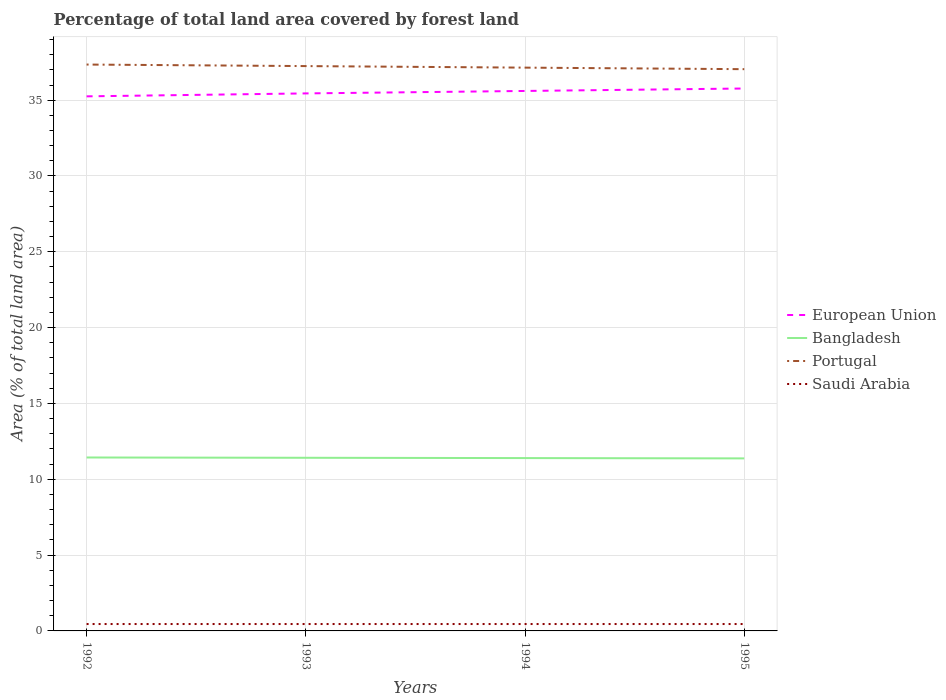How many different coloured lines are there?
Your answer should be compact. 4. Across all years, what is the maximum percentage of forest land in European Union?
Offer a terse response. 35.25. In which year was the percentage of forest land in Portugal maximum?
Ensure brevity in your answer.  1995. What is the total percentage of forest land in Bangladesh in the graph?
Your response must be concise. 0.02. What is the difference between the highest and the second highest percentage of forest land in Bangladesh?
Give a very brief answer. 0.06. What is the difference between the highest and the lowest percentage of forest land in Bangladesh?
Offer a very short reply. 2. How many lines are there?
Provide a succinct answer. 4. Are the values on the major ticks of Y-axis written in scientific E-notation?
Keep it short and to the point. No. What is the title of the graph?
Your response must be concise. Percentage of total land area covered by forest land. What is the label or title of the Y-axis?
Make the answer very short. Area (% of total land area). What is the Area (% of total land area) in European Union in 1992?
Offer a terse response. 35.25. What is the Area (% of total land area) of Bangladesh in 1992?
Ensure brevity in your answer.  11.44. What is the Area (% of total land area) in Portugal in 1992?
Keep it short and to the point. 37.35. What is the Area (% of total land area) in Saudi Arabia in 1992?
Offer a terse response. 0.45. What is the Area (% of total land area) in European Union in 1993?
Your response must be concise. 35.45. What is the Area (% of total land area) of Bangladesh in 1993?
Offer a terse response. 11.42. What is the Area (% of total land area) of Portugal in 1993?
Your answer should be very brief. 37.25. What is the Area (% of total land area) of Saudi Arabia in 1993?
Your answer should be compact. 0.45. What is the Area (% of total land area) of European Union in 1994?
Make the answer very short. 35.61. What is the Area (% of total land area) of Bangladesh in 1994?
Offer a terse response. 11.4. What is the Area (% of total land area) of Portugal in 1994?
Your response must be concise. 37.15. What is the Area (% of total land area) of Saudi Arabia in 1994?
Keep it short and to the point. 0.45. What is the Area (% of total land area) in European Union in 1995?
Offer a terse response. 35.77. What is the Area (% of total land area) of Bangladesh in 1995?
Your answer should be compact. 11.38. What is the Area (% of total land area) of Portugal in 1995?
Offer a terse response. 37.04. What is the Area (% of total land area) of Saudi Arabia in 1995?
Offer a very short reply. 0.45. Across all years, what is the maximum Area (% of total land area) in European Union?
Make the answer very short. 35.77. Across all years, what is the maximum Area (% of total land area) in Bangladesh?
Your answer should be compact. 11.44. Across all years, what is the maximum Area (% of total land area) of Portugal?
Give a very brief answer. 37.35. Across all years, what is the maximum Area (% of total land area) of Saudi Arabia?
Provide a short and direct response. 0.45. Across all years, what is the minimum Area (% of total land area) of European Union?
Your answer should be very brief. 35.25. Across all years, what is the minimum Area (% of total land area) in Bangladesh?
Make the answer very short. 11.38. Across all years, what is the minimum Area (% of total land area) in Portugal?
Your answer should be very brief. 37.04. Across all years, what is the minimum Area (% of total land area) of Saudi Arabia?
Keep it short and to the point. 0.45. What is the total Area (% of total land area) of European Union in the graph?
Offer a terse response. 142.07. What is the total Area (% of total land area) in Bangladesh in the graph?
Make the answer very short. 45.63. What is the total Area (% of total land area) of Portugal in the graph?
Offer a very short reply. 148.78. What is the total Area (% of total land area) of Saudi Arabia in the graph?
Make the answer very short. 1.82. What is the difference between the Area (% of total land area) in European Union in 1992 and that in 1993?
Offer a terse response. -0.19. What is the difference between the Area (% of total land area) in Bangladesh in 1992 and that in 1993?
Your answer should be compact. 0.02. What is the difference between the Area (% of total land area) in Portugal in 1992 and that in 1993?
Make the answer very short. 0.1. What is the difference between the Area (% of total land area) of European Union in 1992 and that in 1994?
Give a very brief answer. -0.35. What is the difference between the Area (% of total land area) in Bangladesh in 1992 and that in 1994?
Your response must be concise. 0.04. What is the difference between the Area (% of total land area) in Portugal in 1992 and that in 1994?
Your answer should be very brief. 0.2. What is the difference between the Area (% of total land area) in Saudi Arabia in 1992 and that in 1994?
Keep it short and to the point. 0. What is the difference between the Area (% of total land area) in European Union in 1992 and that in 1995?
Keep it short and to the point. -0.52. What is the difference between the Area (% of total land area) of Bangladesh in 1992 and that in 1995?
Ensure brevity in your answer.  0.06. What is the difference between the Area (% of total land area) in Portugal in 1992 and that in 1995?
Your answer should be compact. 0.3. What is the difference between the Area (% of total land area) in Saudi Arabia in 1992 and that in 1995?
Your answer should be very brief. 0. What is the difference between the Area (% of total land area) of European Union in 1993 and that in 1994?
Keep it short and to the point. -0.16. What is the difference between the Area (% of total land area) of Portugal in 1993 and that in 1994?
Your answer should be very brief. 0.1. What is the difference between the Area (% of total land area) in Saudi Arabia in 1993 and that in 1994?
Make the answer very short. 0. What is the difference between the Area (% of total land area) of European Union in 1993 and that in 1995?
Your response must be concise. -0.32. What is the difference between the Area (% of total land area) in Bangladesh in 1993 and that in 1995?
Your response must be concise. 0.04. What is the difference between the Area (% of total land area) in Portugal in 1993 and that in 1995?
Offer a terse response. 0.2. What is the difference between the Area (% of total land area) in Saudi Arabia in 1993 and that in 1995?
Offer a very short reply. 0. What is the difference between the Area (% of total land area) of European Union in 1994 and that in 1995?
Make the answer very short. -0.16. What is the difference between the Area (% of total land area) in Portugal in 1994 and that in 1995?
Your answer should be very brief. 0.1. What is the difference between the Area (% of total land area) of European Union in 1992 and the Area (% of total land area) of Bangladesh in 1993?
Ensure brevity in your answer.  23.83. What is the difference between the Area (% of total land area) in European Union in 1992 and the Area (% of total land area) in Portugal in 1993?
Give a very brief answer. -1.99. What is the difference between the Area (% of total land area) in European Union in 1992 and the Area (% of total land area) in Saudi Arabia in 1993?
Your answer should be compact. 34.8. What is the difference between the Area (% of total land area) of Bangladesh in 1992 and the Area (% of total land area) of Portugal in 1993?
Keep it short and to the point. -25.81. What is the difference between the Area (% of total land area) in Bangladesh in 1992 and the Area (% of total land area) in Saudi Arabia in 1993?
Your answer should be very brief. 10.98. What is the difference between the Area (% of total land area) of Portugal in 1992 and the Area (% of total land area) of Saudi Arabia in 1993?
Keep it short and to the point. 36.89. What is the difference between the Area (% of total land area) of European Union in 1992 and the Area (% of total land area) of Bangladesh in 1994?
Provide a succinct answer. 23.85. What is the difference between the Area (% of total land area) of European Union in 1992 and the Area (% of total land area) of Portugal in 1994?
Your answer should be compact. -1.89. What is the difference between the Area (% of total land area) of European Union in 1992 and the Area (% of total land area) of Saudi Arabia in 1994?
Offer a terse response. 34.8. What is the difference between the Area (% of total land area) in Bangladesh in 1992 and the Area (% of total land area) in Portugal in 1994?
Your answer should be compact. -25.71. What is the difference between the Area (% of total land area) of Bangladesh in 1992 and the Area (% of total land area) of Saudi Arabia in 1994?
Your response must be concise. 10.98. What is the difference between the Area (% of total land area) in Portugal in 1992 and the Area (% of total land area) in Saudi Arabia in 1994?
Keep it short and to the point. 36.89. What is the difference between the Area (% of total land area) of European Union in 1992 and the Area (% of total land area) of Bangladesh in 1995?
Keep it short and to the point. 23.87. What is the difference between the Area (% of total land area) in European Union in 1992 and the Area (% of total land area) in Portugal in 1995?
Ensure brevity in your answer.  -1.79. What is the difference between the Area (% of total land area) in European Union in 1992 and the Area (% of total land area) in Saudi Arabia in 1995?
Give a very brief answer. 34.8. What is the difference between the Area (% of total land area) of Bangladesh in 1992 and the Area (% of total land area) of Portugal in 1995?
Your answer should be very brief. -25.61. What is the difference between the Area (% of total land area) of Bangladesh in 1992 and the Area (% of total land area) of Saudi Arabia in 1995?
Offer a terse response. 10.98. What is the difference between the Area (% of total land area) in Portugal in 1992 and the Area (% of total land area) in Saudi Arabia in 1995?
Make the answer very short. 36.89. What is the difference between the Area (% of total land area) in European Union in 1993 and the Area (% of total land area) in Bangladesh in 1994?
Your answer should be very brief. 24.05. What is the difference between the Area (% of total land area) of European Union in 1993 and the Area (% of total land area) of Portugal in 1994?
Ensure brevity in your answer.  -1.7. What is the difference between the Area (% of total land area) of European Union in 1993 and the Area (% of total land area) of Saudi Arabia in 1994?
Make the answer very short. 34.99. What is the difference between the Area (% of total land area) in Bangladesh in 1993 and the Area (% of total land area) in Portugal in 1994?
Provide a short and direct response. -25.73. What is the difference between the Area (% of total land area) of Bangladesh in 1993 and the Area (% of total land area) of Saudi Arabia in 1994?
Make the answer very short. 10.96. What is the difference between the Area (% of total land area) of Portugal in 1993 and the Area (% of total land area) of Saudi Arabia in 1994?
Ensure brevity in your answer.  36.79. What is the difference between the Area (% of total land area) in European Union in 1993 and the Area (% of total land area) in Bangladesh in 1995?
Offer a very short reply. 24.07. What is the difference between the Area (% of total land area) of European Union in 1993 and the Area (% of total land area) of Portugal in 1995?
Make the answer very short. -1.6. What is the difference between the Area (% of total land area) of European Union in 1993 and the Area (% of total land area) of Saudi Arabia in 1995?
Your response must be concise. 34.99. What is the difference between the Area (% of total land area) of Bangladesh in 1993 and the Area (% of total land area) of Portugal in 1995?
Offer a terse response. -25.63. What is the difference between the Area (% of total land area) of Bangladesh in 1993 and the Area (% of total land area) of Saudi Arabia in 1995?
Provide a short and direct response. 10.96. What is the difference between the Area (% of total land area) in Portugal in 1993 and the Area (% of total land area) in Saudi Arabia in 1995?
Provide a succinct answer. 36.79. What is the difference between the Area (% of total land area) of European Union in 1994 and the Area (% of total land area) of Bangladesh in 1995?
Your answer should be very brief. 24.23. What is the difference between the Area (% of total land area) of European Union in 1994 and the Area (% of total land area) of Portugal in 1995?
Give a very brief answer. -1.44. What is the difference between the Area (% of total land area) in European Union in 1994 and the Area (% of total land area) in Saudi Arabia in 1995?
Provide a succinct answer. 35.15. What is the difference between the Area (% of total land area) in Bangladesh in 1994 and the Area (% of total land area) in Portugal in 1995?
Offer a very short reply. -25.65. What is the difference between the Area (% of total land area) of Bangladesh in 1994 and the Area (% of total land area) of Saudi Arabia in 1995?
Your answer should be compact. 10.94. What is the difference between the Area (% of total land area) of Portugal in 1994 and the Area (% of total land area) of Saudi Arabia in 1995?
Give a very brief answer. 36.69. What is the average Area (% of total land area) in European Union per year?
Give a very brief answer. 35.52. What is the average Area (% of total land area) of Bangladesh per year?
Provide a succinct answer. 11.41. What is the average Area (% of total land area) in Portugal per year?
Your answer should be very brief. 37.2. What is the average Area (% of total land area) in Saudi Arabia per year?
Make the answer very short. 0.45. In the year 1992, what is the difference between the Area (% of total land area) of European Union and Area (% of total land area) of Bangladesh?
Ensure brevity in your answer.  23.81. In the year 1992, what is the difference between the Area (% of total land area) of European Union and Area (% of total land area) of Portugal?
Your answer should be compact. -2.1. In the year 1992, what is the difference between the Area (% of total land area) in European Union and Area (% of total land area) in Saudi Arabia?
Offer a terse response. 34.8. In the year 1992, what is the difference between the Area (% of total land area) in Bangladesh and Area (% of total land area) in Portugal?
Provide a short and direct response. -25.91. In the year 1992, what is the difference between the Area (% of total land area) of Bangladesh and Area (% of total land area) of Saudi Arabia?
Your response must be concise. 10.98. In the year 1992, what is the difference between the Area (% of total land area) of Portugal and Area (% of total land area) of Saudi Arabia?
Ensure brevity in your answer.  36.89. In the year 1993, what is the difference between the Area (% of total land area) in European Union and Area (% of total land area) in Bangladesh?
Your response must be concise. 24.03. In the year 1993, what is the difference between the Area (% of total land area) of European Union and Area (% of total land area) of Portugal?
Provide a short and direct response. -1.8. In the year 1993, what is the difference between the Area (% of total land area) of European Union and Area (% of total land area) of Saudi Arabia?
Offer a terse response. 34.99. In the year 1993, what is the difference between the Area (% of total land area) of Bangladesh and Area (% of total land area) of Portugal?
Provide a short and direct response. -25.83. In the year 1993, what is the difference between the Area (% of total land area) of Bangladesh and Area (% of total land area) of Saudi Arabia?
Your response must be concise. 10.96. In the year 1993, what is the difference between the Area (% of total land area) in Portugal and Area (% of total land area) in Saudi Arabia?
Make the answer very short. 36.79. In the year 1994, what is the difference between the Area (% of total land area) of European Union and Area (% of total land area) of Bangladesh?
Keep it short and to the point. 24.21. In the year 1994, what is the difference between the Area (% of total land area) of European Union and Area (% of total land area) of Portugal?
Your answer should be compact. -1.54. In the year 1994, what is the difference between the Area (% of total land area) of European Union and Area (% of total land area) of Saudi Arabia?
Your answer should be compact. 35.15. In the year 1994, what is the difference between the Area (% of total land area) in Bangladesh and Area (% of total land area) in Portugal?
Your answer should be compact. -25.75. In the year 1994, what is the difference between the Area (% of total land area) in Bangladesh and Area (% of total land area) in Saudi Arabia?
Your answer should be very brief. 10.94. In the year 1994, what is the difference between the Area (% of total land area) in Portugal and Area (% of total land area) in Saudi Arabia?
Your answer should be very brief. 36.69. In the year 1995, what is the difference between the Area (% of total land area) in European Union and Area (% of total land area) in Bangladesh?
Your response must be concise. 24.39. In the year 1995, what is the difference between the Area (% of total land area) of European Union and Area (% of total land area) of Portugal?
Provide a short and direct response. -1.27. In the year 1995, what is the difference between the Area (% of total land area) of European Union and Area (% of total land area) of Saudi Arabia?
Provide a short and direct response. 35.31. In the year 1995, what is the difference between the Area (% of total land area) in Bangladesh and Area (% of total land area) in Portugal?
Your answer should be compact. -25.67. In the year 1995, what is the difference between the Area (% of total land area) of Bangladesh and Area (% of total land area) of Saudi Arabia?
Keep it short and to the point. 10.92. In the year 1995, what is the difference between the Area (% of total land area) in Portugal and Area (% of total land area) in Saudi Arabia?
Your answer should be very brief. 36.59. What is the ratio of the Area (% of total land area) of European Union in 1992 to that in 1993?
Provide a succinct answer. 0.99. What is the ratio of the Area (% of total land area) of Portugal in 1992 to that in 1993?
Provide a short and direct response. 1. What is the ratio of the Area (% of total land area) in Bangladesh in 1992 to that in 1994?
Ensure brevity in your answer.  1. What is the ratio of the Area (% of total land area) of European Union in 1992 to that in 1995?
Give a very brief answer. 0.99. What is the ratio of the Area (% of total land area) of Bangladesh in 1992 to that in 1995?
Ensure brevity in your answer.  1.01. What is the ratio of the Area (% of total land area) of Portugal in 1992 to that in 1995?
Give a very brief answer. 1.01. What is the ratio of the Area (% of total land area) of Saudi Arabia in 1992 to that in 1995?
Ensure brevity in your answer.  1. What is the ratio of the Area (% of total land area) in European Union in 1993 to that in 1994?
Make the answer very short. 1. What is the ratio of the Area (% of total land area) in Bangladesh in 1993 to that in 1994?
Offer a very short reply. 1. What is the ratio of the Area (% of total land area) of Portugal in 1993 to that in 1994?
Your response must be concise. 1. What is the ratio of the Area (% of total land area) in European Union in 1993 to that in 1995?
Offer a very short reply. 0.99. What is the ratio of the Area (% of total land area) of Portugal in 1993 to that in 1995?
Offer a very short reply. 1.01. What is the ratio of the Area (% of total land area) of Saudi Arabia in 1993 to that in 1995?
Offer a very short reply. 1. What is the ratio of the Area (% of total land area) in European Union in 1994 to that in 1995?
Ensure brevity in your answer.  1. What is the ratio of the Area (% of total land area) in Portugal in 1994 to that in 1995?
Provide a short and direct response. 1. What is the difference between the highest and the second highest Area (% of total land area) of European Union?
Offer a very short reply. 0.16. What is the difference between the highest and the second highest Area (% of total land area) in Portugal?
Ensure brevity in your answer.  0.1. What is the difference between the highest and the second highest Area (% of total land area) of Saudi Arabia?
Offer a very short reply. 0. What is the difference between the highest and the lowest Area (% of total land area) in European Union?
Your response must be concise. 0.52. What is the difference between the highest and the lowest Area (% of total land area) in Bangladesh?
Provide a short and direct response. 0.06. What is the difference between the highest and the lowest Area (% of total land area) in Portugal?
Offer a terse response. 0.3. What is the difference between the highest and the lowest Area (% of total land area) of Saudi Arabia?
Ensure brevity in your answer.  0. 